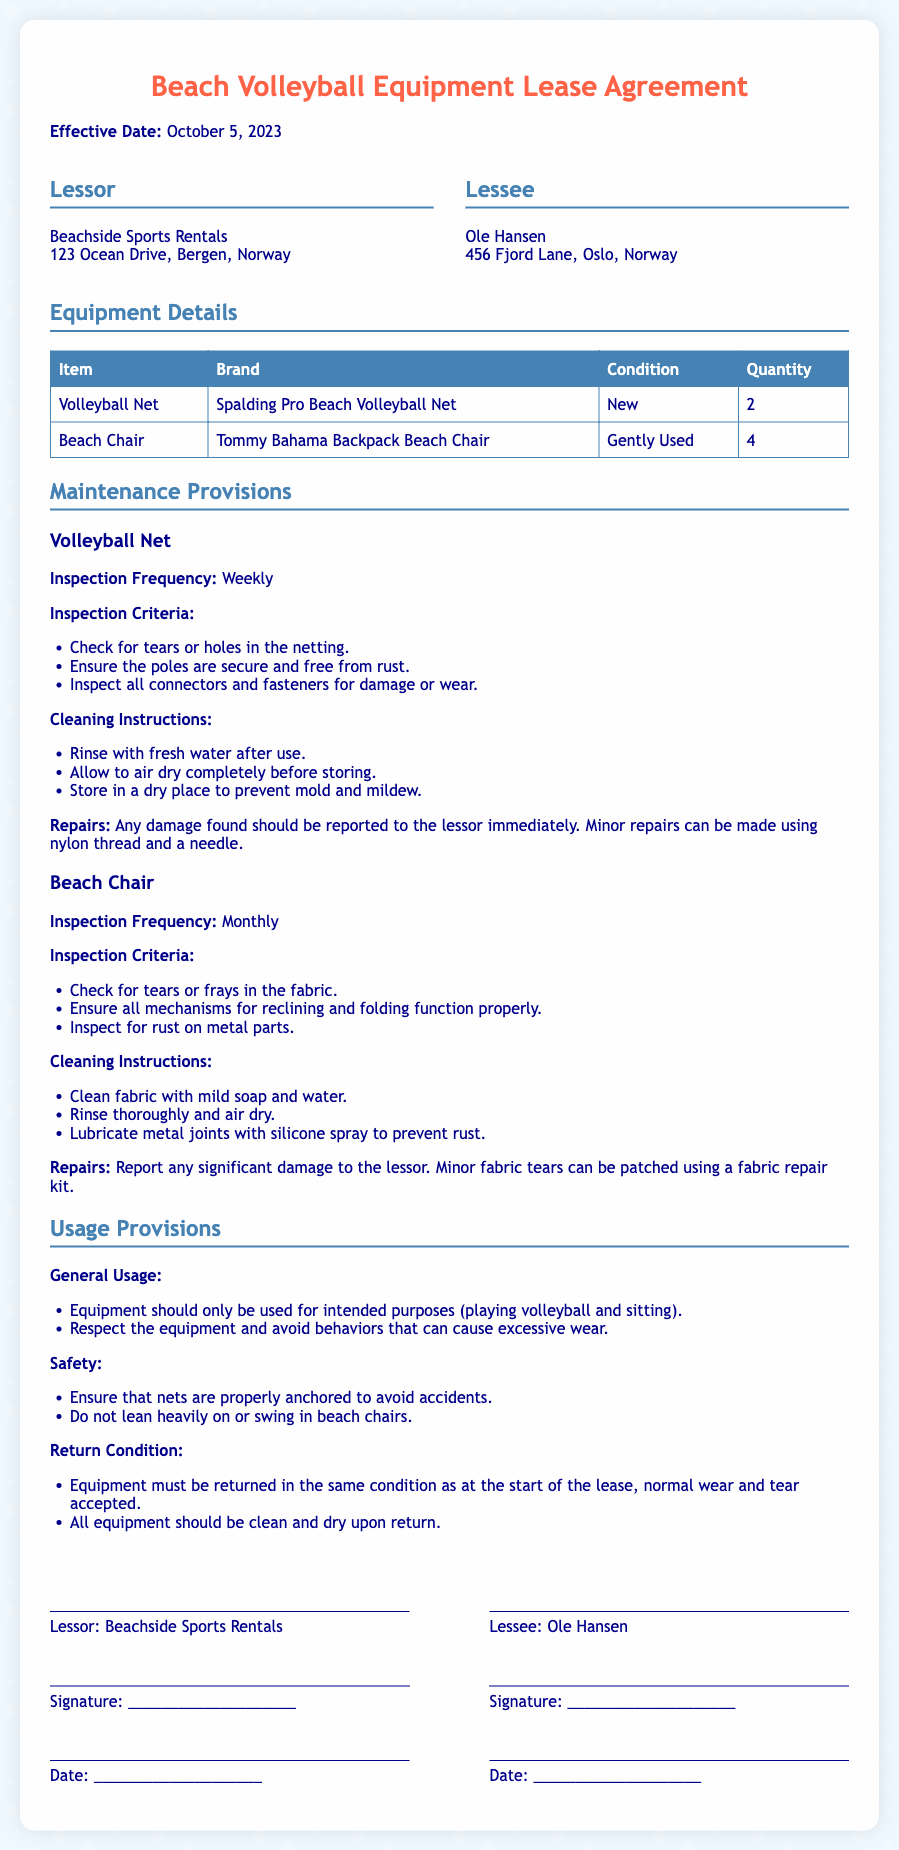What is the effective date of the lease? The effective date is specified at the beginning of the document as the date when the lease agreement comes into force.
Answer: October 5, 2023 How many volleyball nets are included in the lease? The lease document specifies the quantity of the volleyball nets in the equipment details table.
Answer: 2 What is the brand of the beach chair? The equipment details section includes the brand names of each item, specifically listing the beach chair's brand.
Answer: Tommy Bahama What is the inspection frequency for the volleyball net? The inspection frequency is mentioned under the maintenance provisions for the volleyball net section.
Answer: Weekly What should be done if damage is found on the volleyball net? The document outlines the maintenance provisions, detailing the procedure for reporting damage on the volleyball net.
Answer: Report to the lessor What are the general usage instructions for the equipment? The general usage provisions detail the intended purposes and respectful usage guidelines for the equipment.
Answer: Intended purposes What should be done to the beach chairs before returning them? The return condition section specifies the requirements for the equipment's condition upon return.
Answer: Clean and dry How often should the beach chair be inspected? The maintenance provisions specify the frequency of inspections for each equipment in separate sections.
Answer: Monthly What is the condition of the beach chairs listed in the equipment details? The current status or quality of each item is noted in the equipment details table.
Answer: Gently Used 